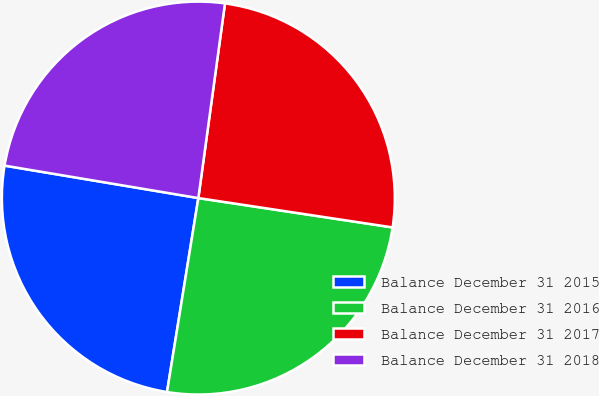Convert chart. <chart><loc_0><loc_0><loc_500><loc_500><pie_chart><fcel>Balance December 31 2015<fcel>Balance December 31 2016<fcel>Balance December 31 2017<fcel>Balance December 31 2018<nl><fcel>25.09%<fcel>25.16%<fcel>25.22%<fcel>24.52%<nl></chart> 